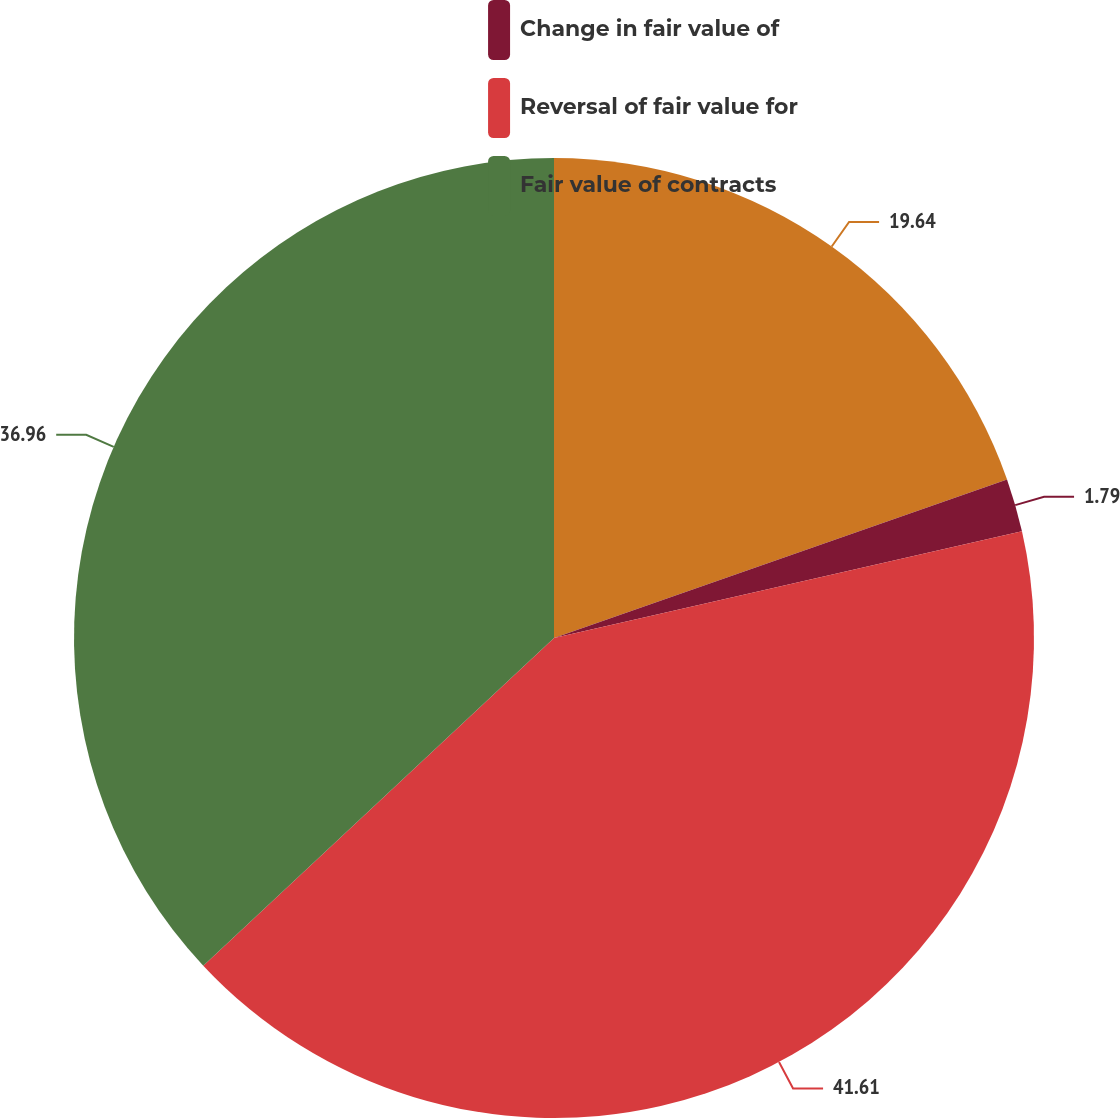Convert chart. <chart><loc_0><loc_0><loc_500><loc_500><pie_chart><ecel><fcel>Change in fair value of<fcel>Reversal of fair value for<fcel>Fair value of contracts<nl><fcel>19.64%<fcel>1.79%<fcel>41.61%<fcel>36.96%<nl></chart> 